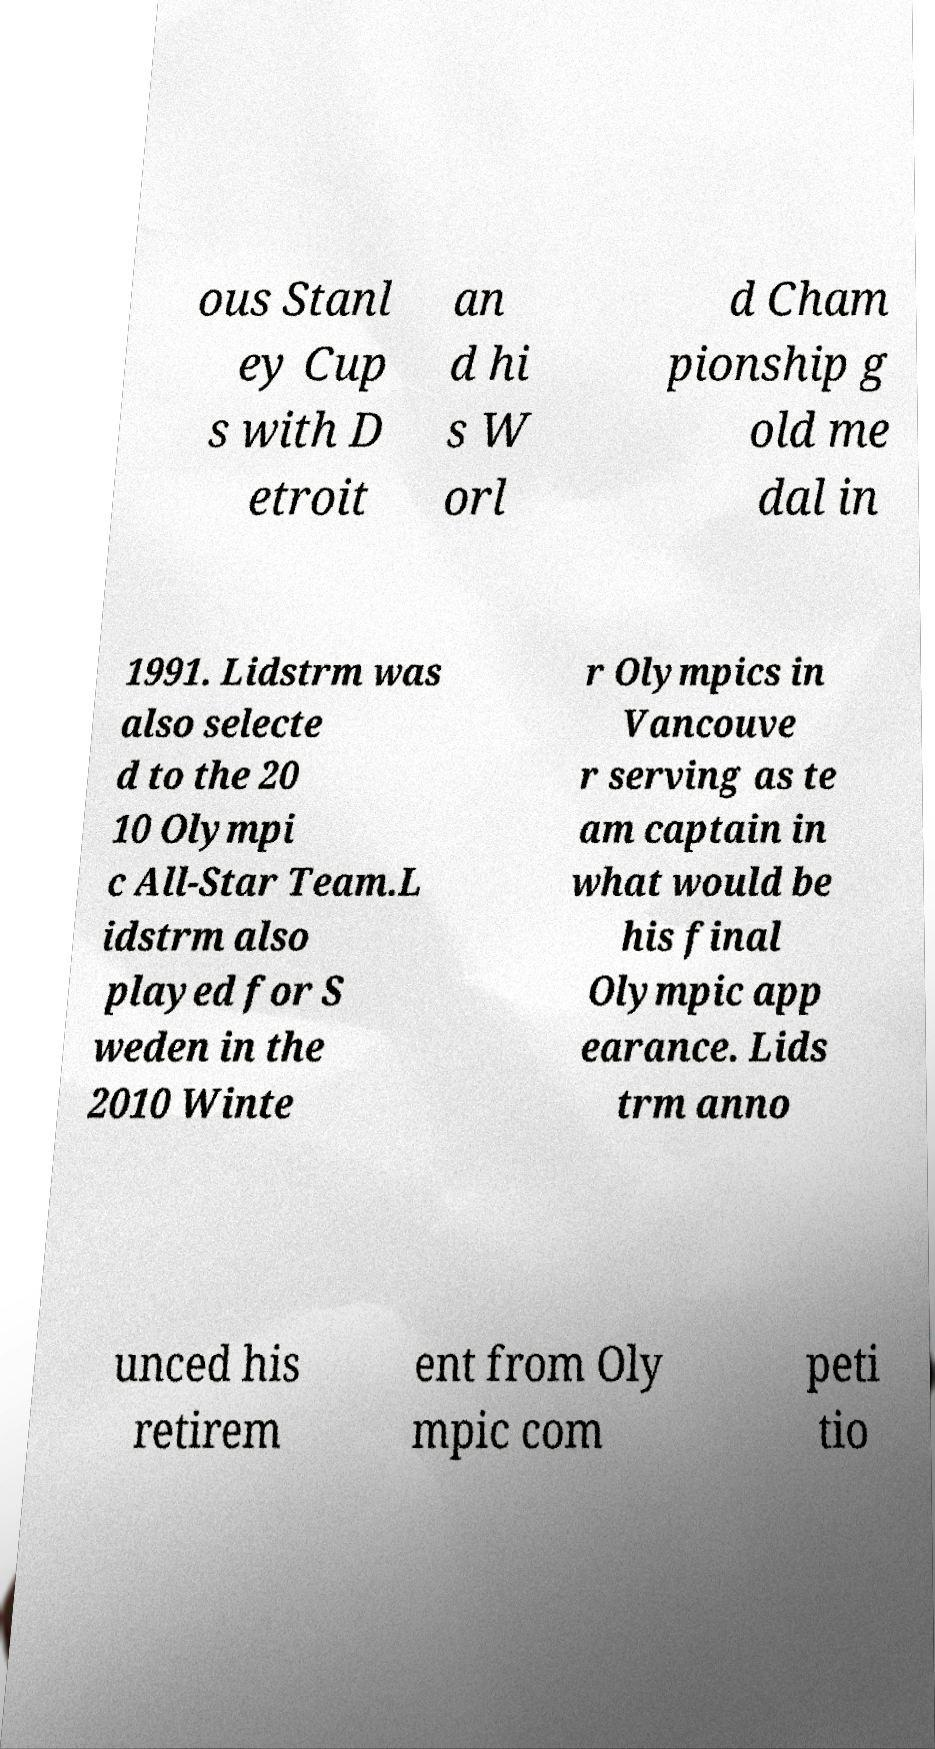For documentation purposes, I need the text within this image transcribed. Could you provide that? ous Stanl ey Cup s with D etroit an d hi s W orl d Cham pionship g old me dal in 1991. Lidstrm was also selecte d to the 20 10 Olympi c All-Star Team.L idstrm also played for S weden in the 2010 Winte r Olympics in Vancouve r serving as te am captain in what would be his final Olympic app earance. Lids trm anno unced his retirem ent from Oly mpic com peti tio 